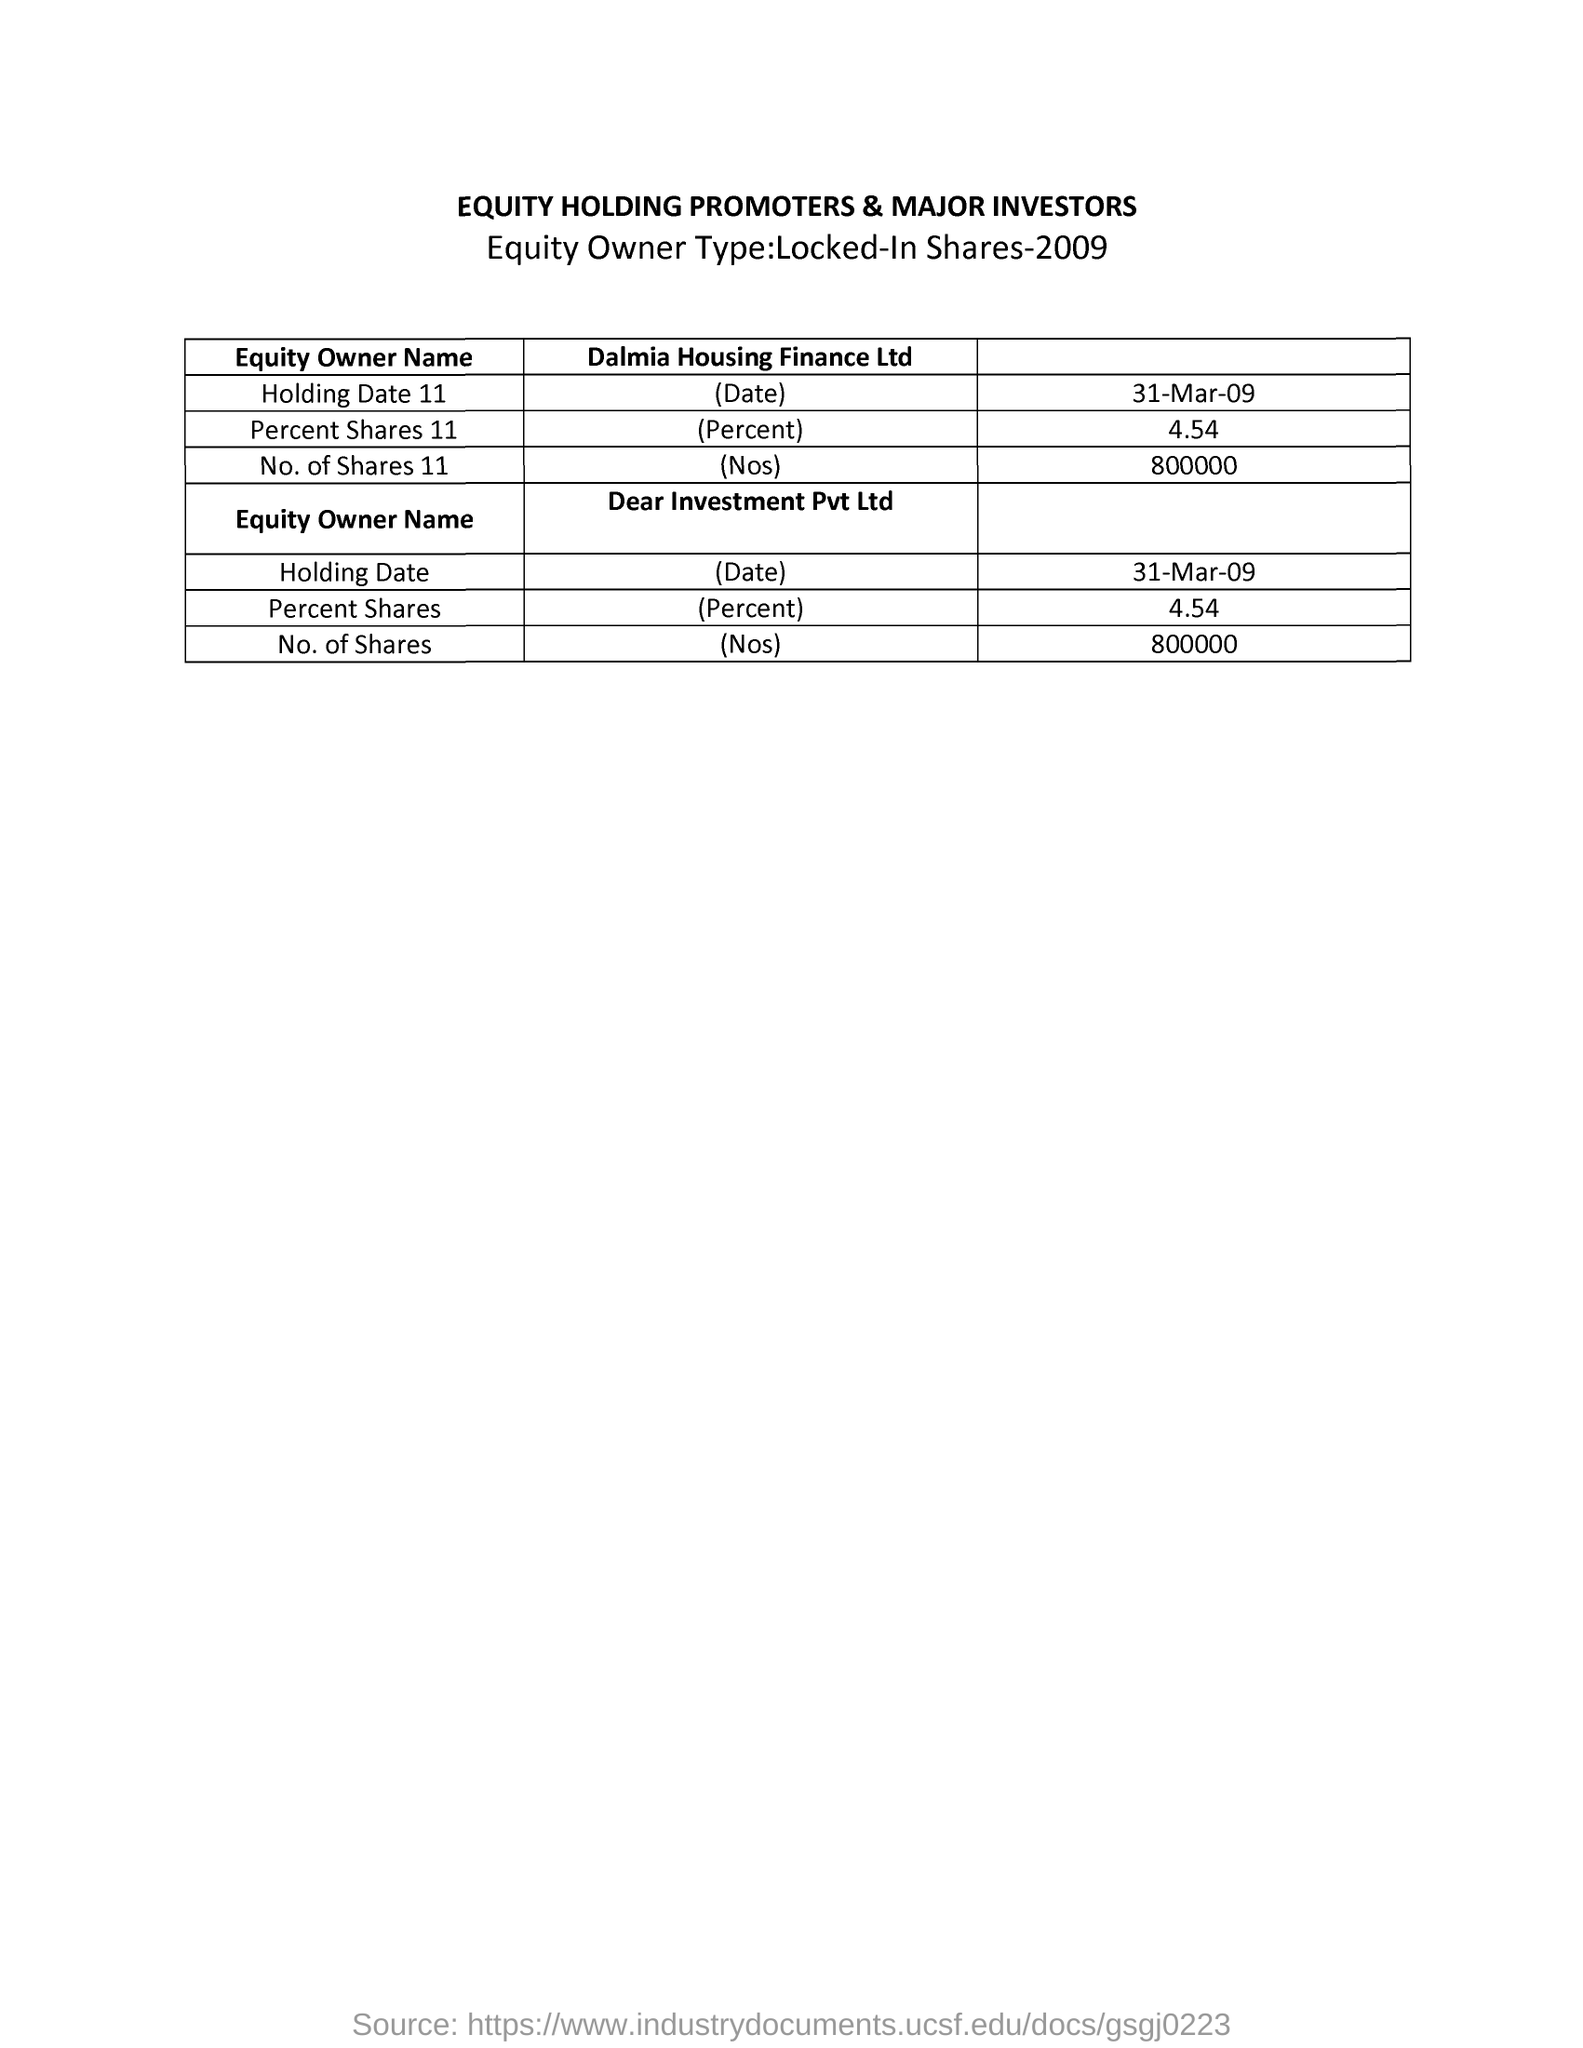What is the title of the given document?
Your answer should be very brief. Equity holding promoters & major investors. What is the year in which equity owner type:locked in shares?
Provide a succinct answer. 2009. What is the holding date 11 in dalmia housing finance ltd?
Your answer should be very brief. 31-mar-09. What is the percent shares 11 in dalmia housing finance ltd?
Offer a terse response. 4.54. What is the total number of shares in dear investment pvt ltd?
Give a very brief answer. 800000. 